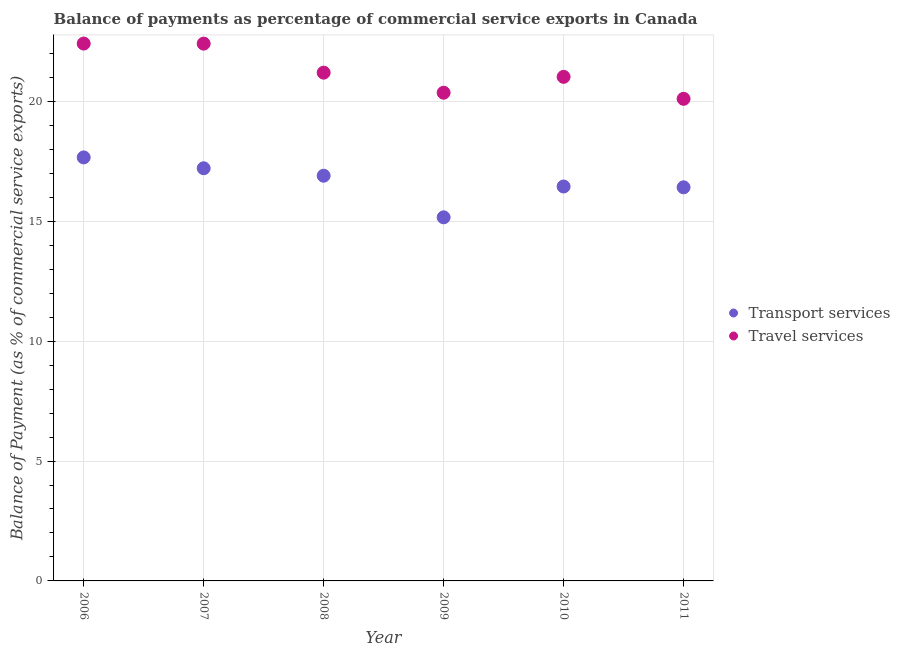Is the number of dotlines equal to the number of legend labels?
Provide a succinct answer. Yes. What is the balance of payments of travel services in 2009?
Provide a succinct answer. 20.36. Across all years, what is the maximum balance of payments of transport services?
Your response must be concise. 17.66. Across all years, what is the minimum balance of payments of transport services?
Offer a very short reply. 15.16. What is the total balance of payments of travel services in the graph?
Your response must be concise. 127.5. What is the difference between the balance of payments of travel services in 2006 and that in 2010?
Give a very brief answer. 1.39. What is the difference between the balance of payments of travel services in 2011 and the balance of payments of transport services in 2008?
Provide a succinct answer. 3.21. What is the average balance of payments of transport services per year?
Give a very brief answer. 16.63. In the year 2011, what is the difference between the balance of payments of transport services and balance of payments of travel services?
Provide a short and direct response. -3.69. In how many years, is the balance of payments of travel services greater than 10 %?
Make the answer very short. 6. What is the ratio of the balance of payments of transport services in 2006 to that in 2009?
Provide a short and direct response. 1.16. Is the balance of payments of transport services in 2009 less than that in 2010?
Provide a succinct answer. Yes. What is the difference between the highest and the second highest balance of payments of travel services?
Make the answer very short. 0. What is the difference between the highest and the lowest balance of payments of transport services?
Provide a short and direct response. 2.5. In how many years, is the balance of payments of transport services greater than the average balance of payments of transport services taken over all years?
Provide a succinct answer. 3. Is the sum of the balance of payments of travel services in 2008 and 2010 greater than the maximum balance of payments of transport services across all years?
Provide a succinct answer. Yes. Does the balance of payments of transport services monotonically increase over the years?
Your response must be concise. No. Is the balance of payments of travel services strictly less than the balance of payments of transport services over the years?
Offer a very short reply. No. What is the difference between two consecutive major ticks on the Y-axis?
Provide a succinct answer. 5. Are the values on the major ticks of Y-axis written in scientific E-notation?
Give a very brief answer. No. Where does the legend appear in the graph?
Give a very brief answer. Center right. How many legend labels are there?
Offer a very short reply. 2. How are the legend labels stacked?
Ensure brevity in your answer.  Vertical. What is the title of the graph?
Your answer should be very brief. Balance of payments as percentage of commercial service exports in Canada. Does "Malaria" appear as one of the legend labels in the graph?
Make the answer very short. No. What is the label or title of the Y-axis?
Your answer should be compact. Balance of Payment (as % of commercial service exports). What is the Balance of Payment (as % of commercial service exports) in Transport services in 2006?
Make the answer very short. 17.66. What is the Balance of Payment (as % of commercial service exports) in Travel services in 2006?
Your answer should be very brief. 22.41. What is the Balance of Payment (as % of commercial service exports) of Transport services in 2007?
Ensure brevity in your answer.  17.21. What is the Balance of Payment (as % of commercial service exports) of Travel services in 2007?
Your response must be concise. 22.41. What is the Balance of Payment (as % of commercial service exports) in Transport services in 2008?
Your response must be concise. 16.9. What is the Balance of Payment (as % of commercial service exports) of Travel services in 2008?
Provide a short and direct response. 21.2. What is the Balance of Payment (as % of commercial service exports) in Transport services in 2009?
Your response must be concise. 15.16. What is the Balance of Payment (as % of commercial service exports) of Travel services in 2009?
Offer a very short reply. 20.36. What is the Balance of Payment (as % of commercial service exports) of Transport services in 2010?
Your answer should be compact. 16.45. What is the Balance of Payment (as % of commercial service exports) of Travel services in 2010?
Keep it short and to the point. 21.02. What is the Balance of Payment (as % of commercial service exports) of Transport services in 2011?
Make the answer very short. 16.42. What is the Balance of Payment (as % of commercial service exports) in Travel services in 2011?
Offer a very short reply. 20.11. Across all years, what is the maximum Balance of Payment (as % of commercial service exports) of Transport services?
Give a very brief answer. 17.66. Across all years, what is the maximum Balance of Payment (as % of commercial service exports) of Travel services?
Your response must be concise. 22.41. Across all years, what is the minimum Balance of Payment (as % of commercial service exports) of Transport services?
Keep it short and to the point. 15.16. Across all years, what is the minimum Balance of Payment (as % of commercial service exports) in Travel services?
Provide a succinct answer. 20.11. What is the total Balance of Payment (as % of commercial service exports) of Transport services in the graph?
Provide a short and direct response. 99.8. What is the total Balance of Payment (as % of commercial service exports) in Travel services in the graph?
Give a very brief answer. 127.5. What is the difference between the Balance of Payment (as % of commercial service exports) of Transport services in 2006 and that in 2007?
Provide a succinct answer. 0.45. What is the difference between the Balance of Payment (as % of commercial service exports) of Travel services in 2006 and that in 2007?
Ensure brevity in your answer.  0. What is the difference between the Balance of Payment (as % of commercial service exports) in Transport services in 2006 and that in 2008?
Your answer should be compact. 0.76. What is the difference between the Balance of Payment (as % of commercial service exports) in Travel services in 2006 and that in 2008?
Provide a short and direct response. 1.21. What is the difference between the Balance of Payment (as % of commercial service exports) of Transport services in 2006 and that in 2009?
Keep it short and to the point. 2.5. What is the difference between the Balance of Payment (as % of commercial service exports) in Travel services in 2006 and that in 2009?
Ensure brevity in your answer.  2.05. What is the difference between the Balance of Payment (as % of commercial service exports) in Transport services in 2006 and that in 2010?
Provide a short and direct response. 1.21. What is the difference between the Balance of Payment (as % of commercial service exports) of Travel services in 2006 and that in 2010?
Offer a very short reply. 1.39. What is the difference between the Balance of Payment (as % of commercial service exports) in Transport services in 2006 and that in 2011?
Give a very brief answer. 1.25. What is the difference between the Balance of Payment (as % of commercial service exports) in Travel services in 2006 and that in 2011?
Provide a short and direct response. 2.3. What is the difference between the Balance of Payment (as % of commercial service exports) in Transport services in 2007 and that in 2008?
Your response must be concise. 0.31. What is the difference between the Balance of Payment (as % of commercial service exports) in Travel services in 2007 and that in 2008?
Ensure brevity in your answer.  1.21. What is the difference between the Balance of Payment (as % of commercial service exports) in Transport services in 2007 and that in 2009?
Keep it short and to the point. 2.05. What is the difference between the Balance of Payment (as % of commercial service exports) of Travel services in 2007 and that in 2009?
Provide a short and direct response. 2.05. What is the difference between the Balance of Payment (as % of commercial service exports) of Transport services in 2007 and that in 2010?
Make the answer very short. 0.76. What is the difference between the Balance of Payment (as % of commercial service exports) of Travel services in 2007 and that in 2010?
Give a very brief answer. 1.39. What is the difference between the Balance of Payment (as % of commercial service exports) in Transport services in 2007 and that in 2011?
Your answer should be very brief. 0.79. What is the difference between the Balance of Payment (as % of commercial service exports) in Travel services in 2007 and that in 2011?
Your answer should be compact. 2.3. What is the difference between the Balance of Payment (as % of commercial service exports) of Transport services in 2008 and that in 2009?
Provide a succinct answer. 1.74. What is the difference between the Balance of Payment (as % of commercial service exports) of Travel services in 2008 and that in 2009?
Offer a very short reply. 0.84. What is the difference between the Balance of Payment (as % of commercial service exports) of Transport services in 2008 and that in 2010?
Make the answer very short. 0.45. What is the difference between the Balance of Payment (as % of commercial service exports) of Travel services in 2008 and that in 2010?
Your answer should be compact. 0.17. What is the difference between the Balance of Payment (as % of commercial service exports) of Transport services in 2008 and that in 2011?
Provide a succinct answer. 0.48. What is the difference between the Balance of Payment (as % of commercial service exports) in Travel services in 2008 and that in 2011?
Your answer should be compact. 1.09. What is the difference between the Balance of Payment (as % of commercial service exports) in Transport services in 2009 and that in 2010?
Offer a very short reply. -1.29. What is the difference between the Balance of Payment (as % of commercial service exports) in Travel services in 2009 and that in 2010?
Your answer should be very brief. -0.66. What is the difference between the Balance of Payment (as % of commercial service exports) in Transport services in 2009 and that in 2011?
Your answer should be compact. -1.25. What is the difference between the Balance of Payment (as % of commercial service exports) in Travel services in 2009 and that in 2011?
Provide a succinct answer. 0.25. What is the difference between the Balance of Payment (as % of commercial service exports) in Transport services in 2010 and that in 2011?
Offer a terse response. 0.03. What is the difference between the Balance of Payment (as % of commercial service exports) of Travel services in 2010 and that in 2011?
Your answer should be very brief. 0.92. What is the difference between the Balance of Payment (as % of commercial service exports) in Transport services in 2006 and the Balance of Payment (as % of commercial service exports) in Travel services in 2007?
Offer a very short reply. -4.75. What is the difference between the Balance of Payment (as % of commercial service exports) of Transport services in 2006 and the Balance of Payment (as % of commercial service exports) of Travel services in 2008?
Ensure brevity in your answer.  -3.53. What is the difference between the Balance of Payment (as % of commercial service exports) in Transport services in 2006 and the Balance of Payment (as % of commercial service exports) in Travel services in 2009?
Keep it short and to the point. -2.7. What is the difference between the Balance of Payment (as % of commercial service exports) of Transport services in 2006 and the Balance of Payment (as % of commercial service exports) of Travel services in 2010?
Ensure brevity in your answer.  -3.36. What is the difference between the Balance of Payment (as % of commercial service exports) of Transport services in 2006 and the Balance of Payment (as % of commercial service exports) of Travel services in 2011?
Your answer should be very brief. -2.44. What is the difference between the Balance of Payment (as % of commercial service exports) of Transport services in 2007 and the Balance of Payment (as % of commercial service exports) of Travel services in 2008?
Offer a terse response. -3.99. What is the difference between the Balance of Payment (as % of commercial service exports) in Transport services in 2007 and the Balance of Payment (as % of commercial service exports) in Travel services in 2009?
Give a very brief answer. -3.15. What is the difference between the Balance of Payment (as % of commercial service exports) in Transport services in 2007 and the Balance of Payment (as % of commercial service exports) in Travel services in 2010?
Keep it short and to the point. -3.81. What is the difference between the Balance of Payment (as % of commercial service exports) of Transport services in 2007 and the Balance of Payment (as % of commercial service exports) of Travel services in 2011?
Make the answer very short. -2.9. What is the difference between the Balance of Payment (as % of commercial service exports) of Transport services in 2008 and the Balance of Payment (as % of commercial service exports) of Travel services in 2009?
Make the answer very short. -3.46. What is the difference between the Balance of Payment (as % of commercial service exports) in Transport services in 2008 and the Balance of Payment (as % of commercial service exports) in Travel services in 2010?
Your answer should be very brief. -4.12. What is the difference between the Balance of Payment (as % of commercial service exports) in Transport services in 2008 and the Balance of Payment (as % of commercial service exports) in Travel services in 2011?
Offer a very short reply. -3.21. What is the difference between the Balance of Payment (as % of commercial service exports) in Transport services in 2009 and the Balance of Payment (as % of commercial service exports) in Travel services in 2010?
Keep it short and to the point. -5.86. What is the difference between the Balance of Payment (as % of commercial service exports) of Transport services in 2009 and the Balance of Payment (as % of commercial service exports) of Travel services in 2011?
Offer a very short reply. -4.94. What is the difference between the Balance of Payment (as % of commercial service exports) in Transport services in 2010 and the Balance of Payment (as % of commercial service exports) in Travel services in 2011?
Your answer should be very brief. -3.66. What is the average Balance of Payment (as % of commercial service exports) in Transport services per year?
Provide a short and direct response. 16.63. What is the average Balance of Payment (as % of commercial service exports) of Travel services per year?
Give a very brief answer. 21.25. In the year 2006, what is the difference between the Balance of Payment (as % of commercial service exports) of Transport services and Balance of Payment (as % of commercial service exports) of Travel services?
Offer a terse response. -4.75. In the year 2007, what is the difference between the Balance of Payment (as % of commercial service exports) of Transport services and Balance of Payment (as % of commercial service exports) of Travel services?
Ensure brevity in your answer.  -5.2. In the year 2008, what is the difference between the Balance of Payment (as % of commercial service exports) of Transport services and Balance of Payment (as % of commercial service exports) of Travel services?
Your answer should be very brief. -4.3. In the year 2009, what is the difference between the Balance of Payment (as % of commercial service exports) of Transport services and Balance of Payment (as % of commercial service exports) of Travel services?
Offer a very short reply. -5.2. In the year 2010, what is the difference between the Balance of Payment (as % of commercial service exports) of Transport services and Balance of Payment (as % of commercial service exports) of Travel services?
Keep it short and to the point. -4.57. In the year 2011, what is the difference between the Balance of Payment (as % of commercial service exports) of Transport services and Balance of Payment (as % of commercial service exports) of Travel services?
Offer a terse response. -3.69. What is the ratio of the Balance of Payment (as % of commercial service exports) of Transport services in 2006 to that in 2007?
Your answer should be compact. 1.03. What is the ratio of the Balance of Payment (as % of commercial service exports) of Travel services in 2006 to that in 2007?
Give a very brief answer. 1. What is the ratio of the Balance of Payment (as % of commercial service exports) of Transport services in 2006 to that in 2008?
Keep it short and to the point. 1.05. What is the ratio of the Balance of Payment (as % of commercial service exports) of Travel services in 2006 to that in 2008?
Make the answer very short. 1.06. What is the ratio of the Balance of Payment (as % of commercial service exports) in Transport services in 2006 to that in 2009?
Offer a very short reply. 1.16. What is the ratio of the Balance of Payment (as % of commercial service exports) of Travel services in 2006 to that in 2009?
Ensure brevity in your answer.  1.1. What is the ratio of the Balance of Payment (as % of commercial service exports) in Transport services in 2006 to that in 2010?
Give a very brief answer. 1.07. What is the ratio of the Balance of Payment (as % of commercial service exports) of Travel services in 2006 to that in 2010?
Give a very brief answer. 1.07. What is the ratio of the Balance of Payment (as % of commercial service exports) in Transport services in 2006 to that in 2011?
Your answer should be very brief. 1.08. What is the ratio of the Balance of Payment (as % of commercial service exports) in Travel services in 2006 to that in 2011?
Provide a short and direct response. 1.11. What is the ratio of the Balance of Payment (as % of commercial service exports) of Transport services in 2007 to that in 2008?
Provide a succinct answer. 1.02. What is the ratio of the Balance of Payment (as % of commercial service exports) in Travel services in 2007 to that in 2008?
Make the answer very short. 1.06. What is the ratio of the Balance of Payment (as % of commercial service exports) in Transport services in 2007 to that in 2009?
Provide a short and direct response. 1.13. What is the ratio of the Balance of Payment (as % of commercial service exports) in Travel services in 2007 to that in 2009?
Give a very brief answer. 1.1. What is the ratio of the Balance of Payment (as % of commercial service exports) of Transport services in 2007 to that in 2010?
Keep it short and to the point. 1.05. What is the ratio of the Balance of Payment (as % of commercial service exports) in Travel services in 2007 to that in 2010?
Provide a succinct answer. 1.07. What is the ratio of the Balance of Payment (as % of commercial service exports) of Transport services in 2007 to that in 2011?
Your response must be concise. 1.05. What is the ratio of the Balance of Payment (as % of commercial service exports) of Travel services in 2007 to that in 2011?
Ensure brevity in your answer.  1.11. What is the ratio of the Balance of Payment (as % of commercial service exports) of Transport services in 2008 to that in 2009?
Your answer should be compact. 1.11. What is the ratio of the Balance of Payment (as % of commercial service exports) in Travel services in 2008 to that in 2009?
Provide a succinct answer. 1.04. What is the ratio of the Balance of Payment (as % of commercial service exports) in Transport services in 2008 to that in 2010?
Ensure brevity in your answer.  1.03. What is the ratio of the Balance of Payment (as % of commercial service exports) in Travel services in 2008 to that in 2010?
Your answer should be compact. 1.01. What is the ratio of the Balance of Payment (as % of commercial service exports) of Transport services in 2008 to that in 2011?
Give a very brief answer. 1.03. What is the ratio of the Balance of Payment (as % of commercial service exports) in Travel services in 2008 to that in 2011?
Provide a short and direct response. 1.05. What is the ratio of the Balance of Payment (as % of commercial service exports) of Transport services in 2009 to that in 2010?
Ensure brevity in your answer.  0.92. What is the ratio of the Balance of Payment (as % of commercial service exports) in Travel services in 2009 to that in 2010?
Your answer should be very brief. 0.97. What is the ratio of the Balance of Payment (as % of commercial service exports) in Transport services in 2009 to that in 2011?
Offer a very short reply. 0.92. What is the ratio of the Balance of Payment (as % of commercial service exports) in Travel services in 2009 to that in 2011?
Offer a terse response. 1.01. What is the ratio of the Balance of Payment (as % of commercial service exports) of Transport services in 2010 to that in 2011?
Provide a succinct answer. 1. What is the ratio of the Balance of Payment (as % of commercial service exports) of Travel services in 2010 to that in 2011?
Provide a short and direct response. 1.05. What is the difference between the highest and the second highest Balance of Payment (as % of commercial service exports) of Transport services?
Keep it short and to the point. 0.45. What is the difference between the highest and the second highest Balance of Payment (as % of commercial service exports) of Travel services?
Provide a succinct answer. 0. What is the difference between the highest and the lowest Balance of Payment (as % of commercial service exports) in Transport services?
Give a very brief answer. 2.5. What is the difference between the highest and the lowest Balance of Payment (as % of commercial service exports) of Travel services?
Your answer should be compact. 2.3. 